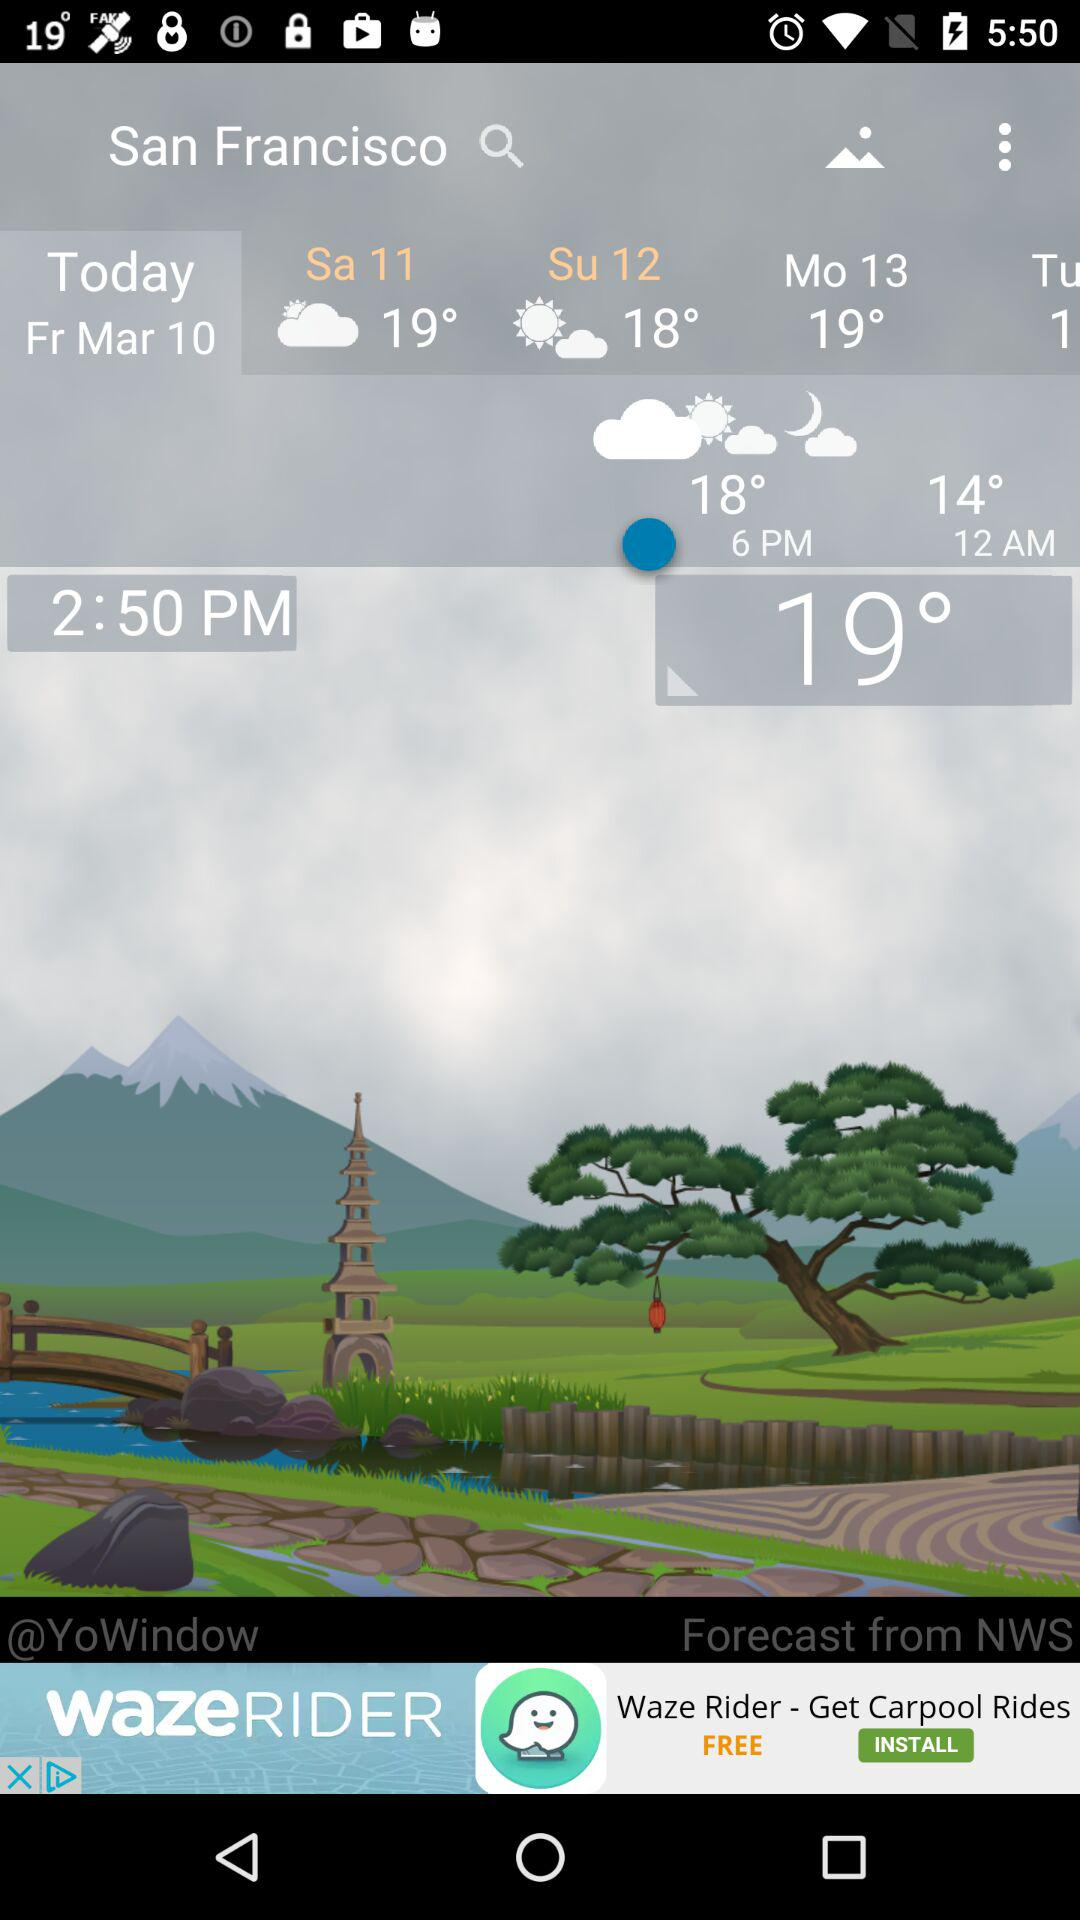How many days does the forecast show?
Answer the question using a single word or phrase. 4 